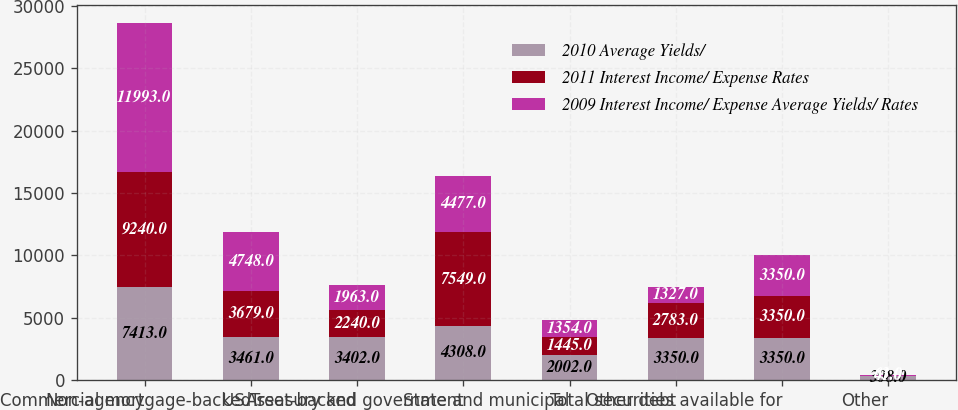Convert chart. <chart><loc_0><loc_0><loc_500><loc_500><stacked_bar_chart><ecel><fcel>Non-agency<fcel>Commercial mortgage-backed<fcel>Asset-backed<fcel>US Treasury and government<fcel>State and municipal<fcel>Other debt<fcel>Total securities available for<fcel>Other<nl><fcel>2010 Average Yields/<fcel>7413<fcel>3461<fcel>3402<fcel>4308<fcel>2002<fcel>3350<fcel>3350<fcel>308<nl><fcel>2011 Interest Income/ Expense Rates<fcel>9240<fcel>3679<fcel>2240<fcel>7549<fcel>1445<fcel>2783<fcel>3350<fcel>41<nl><fcel>2009 Interest Income/ Expense Average Yields/ Rates<fcel>11993<fcel>4748<fcel>1963<fcel>4477<fcel>1354<fcel>1327<fcel>3350<fcel>63<nl></chart> 